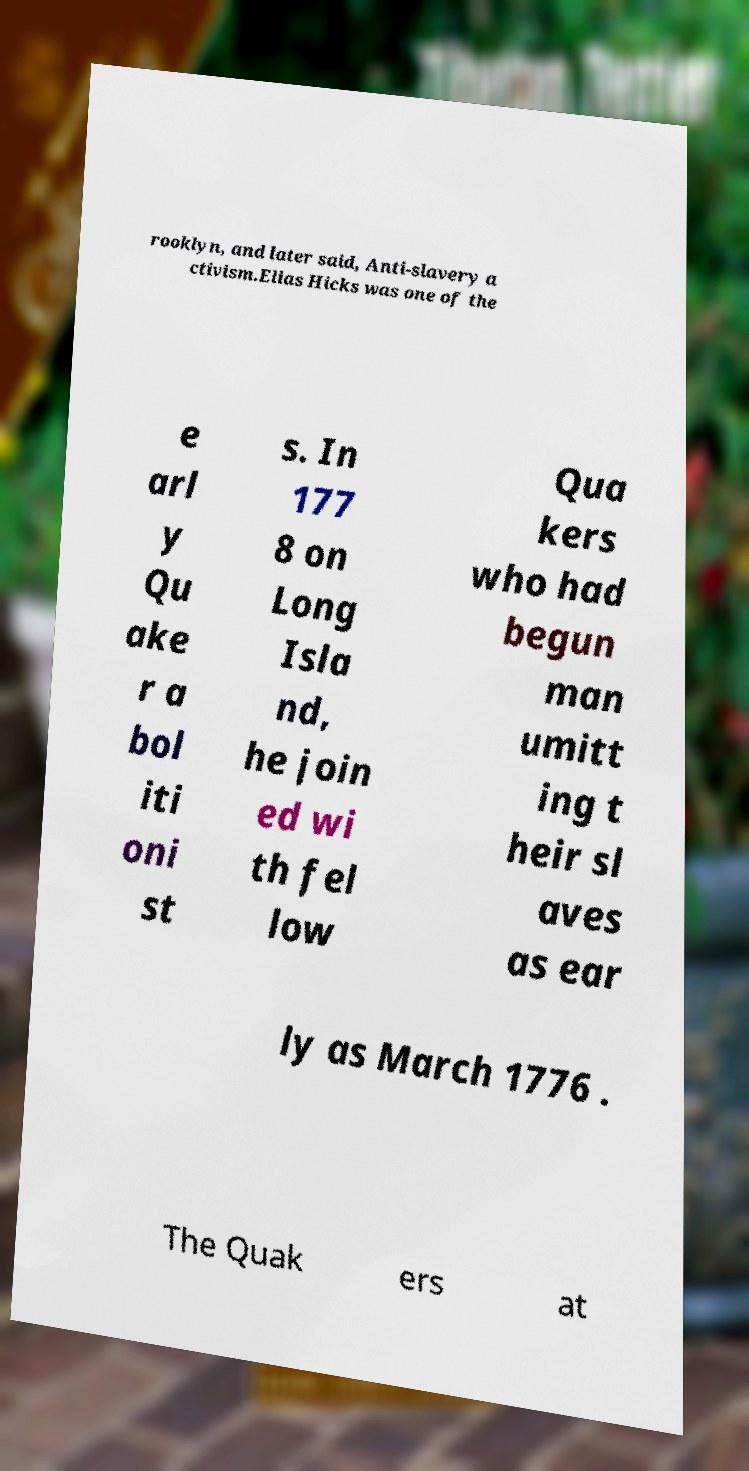For documentation purposes, I need the text within this image transcribed. Could you provide that? rooklyn, and later said, Anti-slavery a ctivism.Elias Hicks was one of the e arl y Qu ake r a bol iti oni st s. In 177 8 on Long Isla nd, he join ed wi th fel low Qua kers who had begun man umitt ing t heir sl aves as ear ly as March 1776 . The Quak ers at 